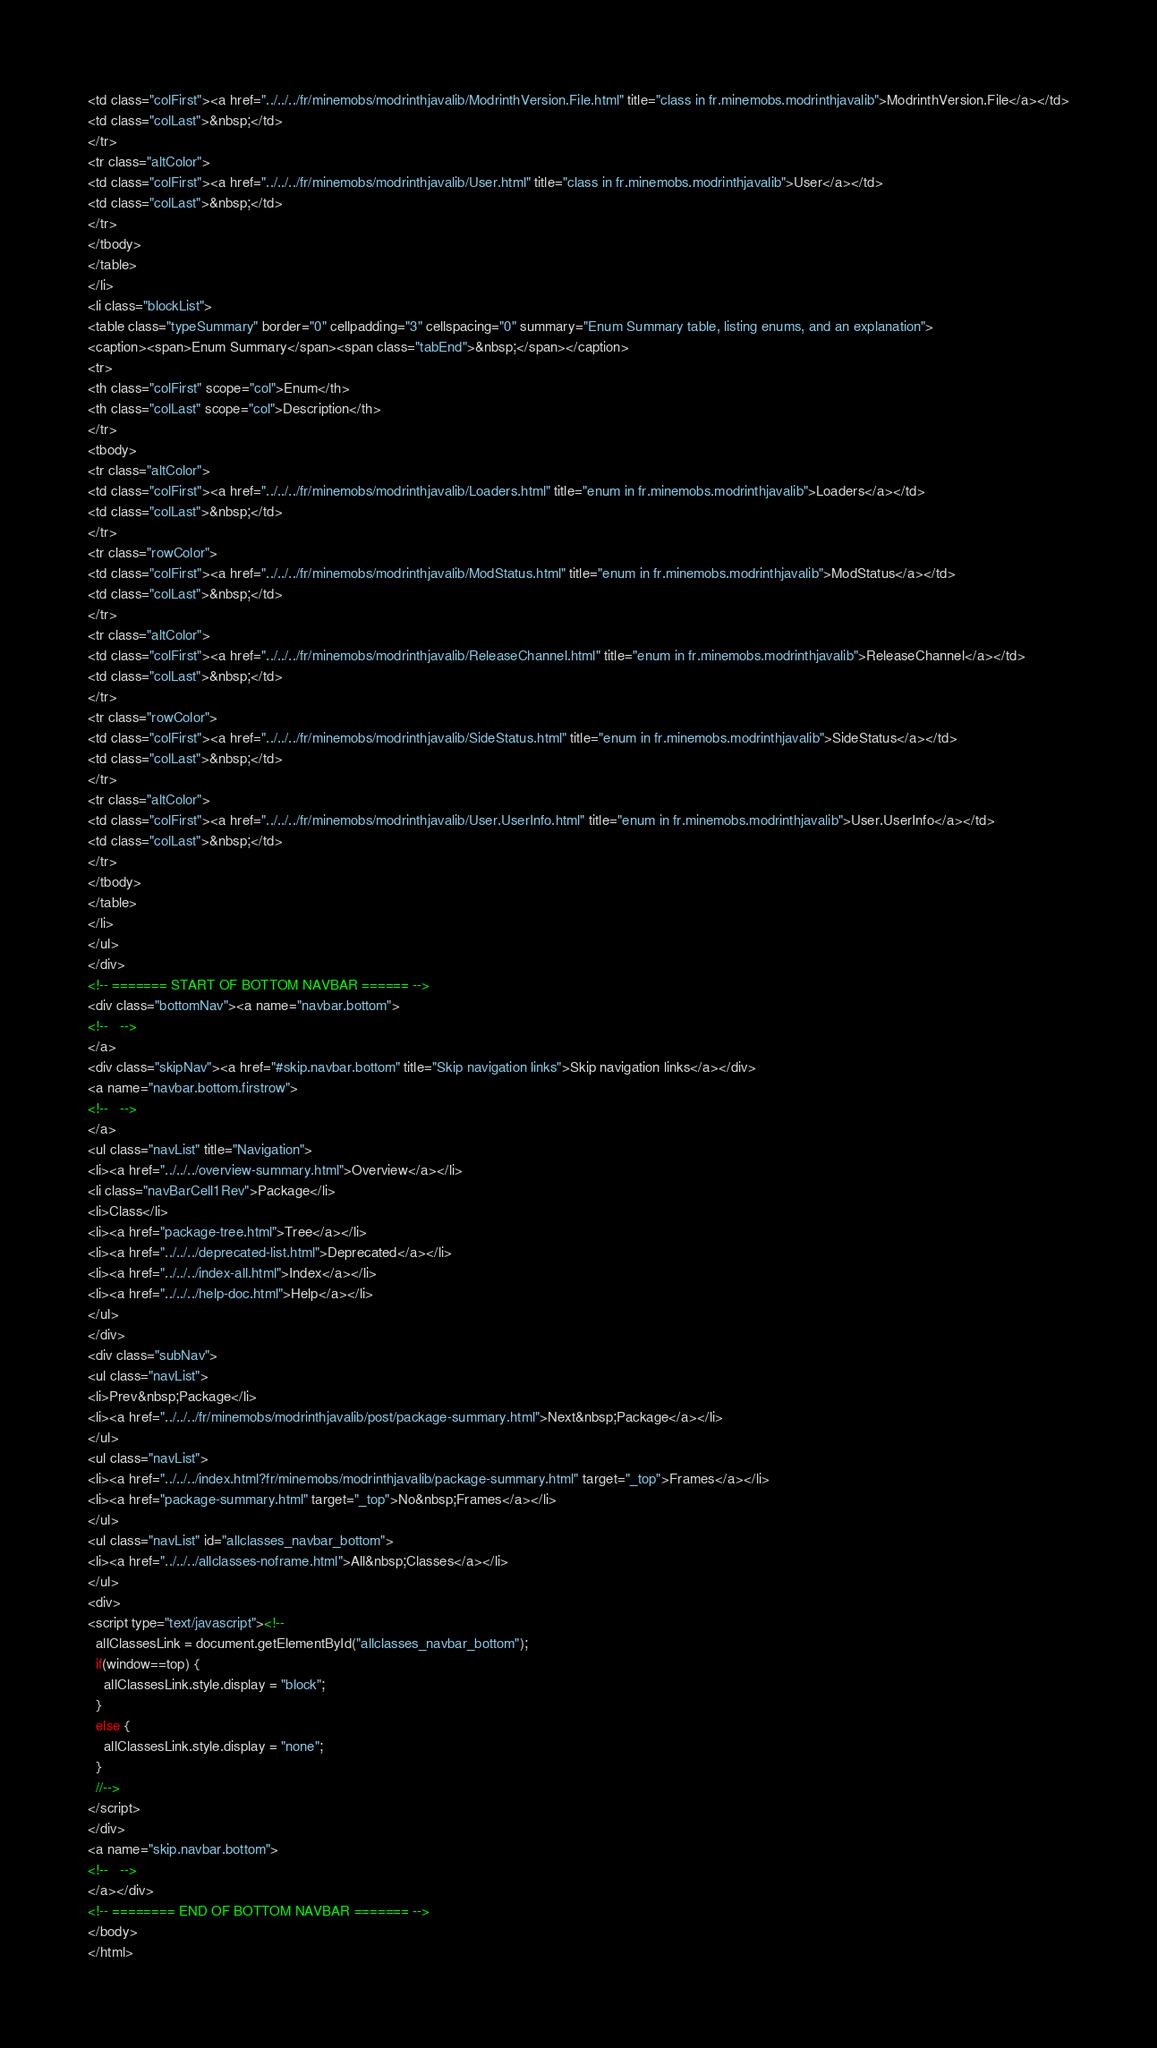<code> <loc_0><loc_0><loc_500><loc_500><_HTML_><td class="colFirst"><a href="../../../fr/minemobs/modrinthjavalib/ModrinthVersion.File.html" title="class in fr.minemobs.modrinthjavalib">ModrinthVersion.File</a></td>
<td class="colLast">&nbsp;</td>
</tr>
<tr class="altColor">
<td class="colFirst"><a href="../../../fr/minemobs/modrinthjavalib/User.html" title="class in fr.minemobs.modrinthjavalib">User</a></td>
<td class="colLast">&nbsp;</td>
</tr>
</tbody>
</table>
</li>
<li class="blockList">
<table class="typeSummary" border="0" cellpadding="3" cellspacing="0" summary="Enum Summary table, listing enums, and an explanation">
<caption><span>Enum Summary</span><span class="tabEnd">&nbsp;</span></caption>
<tr>
<th class="colFirst" scope="col">Enum</th>
<th class="colLast" scope="col">Description</th>
</tr>
<tbody>
<tr class="altColor">
<td class="colFirst"><a href="../../../fr/minemobs/modrinthjavalib/Loaders.html" title="enum in fr.minemobs.modrinthjavalib">Loaders</a></td>
<td class="colLast">&nbsp;</td>
</tr>
<tr class="rowColor">
<td class="colFirst"><a href="../../../fr/minemobs/modrinthjavalib/ModStatus.html" title="enum in fr.minemobs.modrinthjavalib">ModStatus</a></td>
<td class="colLast">&nbsp;</td>
</tr>
<tr class="altColor">
<td class="colFirst"><a href="../../../fr/minemobs/modrinthjavalib/ReleaseChannel.html" title="enum in fr.minemobs.modrinthjavalib">ReleaseChannel</a></td>
<td class="colLast">&nbsp;</td>
</tr>
<tr class="rowColor">
<td class="colFirst"><a href="../../../fr/minemobs/modrinthjavalib/SideStatus.html" title="enum in fr.minemobs.modrinthjavalib">SideStatus</a></td>
<td class="colLast">&nbsp;</td>
</tr>
<tr class="altColor">
<td class="colFirst"><a href="../../../fr/minemobs/modrinthjavalib/User.UserInfo.html" title="enum in fr.minemobs.modrinthjavalib">User.UserInfo</a></td>
<td class="colLast">&nbsp;</td>
</tr>
</tbody>
</table>
</li>
</ul>
</div>
<!-- ======= START OF BOTTOM NAVBAR ====== -->
<div class="bottomNav"><a name="navbar.bottom">
<!--   -->
</a>
<div class="skipNav"><a href="#skip.navbar.bottom" title="Skip navigation links">Skip navigation links</a></div>
<a name="navbar.bottom.firstrow">
<!--   -->
</a>
<ul class="navList" title="Navigation">
<li><a href="../../../overview-summary.html">Overview</a></li>
<li class="navBarCell1Rev">Package</li>
<li>Class</li>
<li><a href="package-tree.html">Tree</a></li>
<li><a href="../../../deprecated-list.html">Deprecated</a></li>
<li><a href="../../../index-all.html">Index</a></li>
<li><a href="../../../help-doc.html">Help</a></li>
</ul>
</div>
<div class="subNav">
<ul class="navList">
<li>Prev&nbsp;Package</li>
<li><a href="../../../fr/minemobs/modrinthjavalib/post/package-summary.html">Next&nbsp;Package</a></li>
</ul>
<ul class="navList">
<li><a href="../../../index.html?fr/minemobs/modrinthjavalib/package-summary.html" target="_top">Frames</a></li>
<li><a href="package-summary.html" target="_top">No&nbsp;Frames</a></li>
</ul>
<ul class="navList" id="allclasses_navbar_bottom">
<li><a href="../../../allclasses-noframe.html">All&nbsp;Classes</a></li>
</ul>
<div>
<script type="text/javascript"><!--
  allClassesLink = document.getElementById("allclasses_navbar_bottom");
  if(window==top) {
    allClassesLink.style.display = "block";
  }
  else {
    allClassesLink.style.display = "none";
  }
  //-->
</script>
</div>
<a name="skip.navbar.bottom">
<!--   -->
</a></div>
<!-- ======== END OF BOTTOM NAVBAR ======= -->
</body>
</html>
</code> 